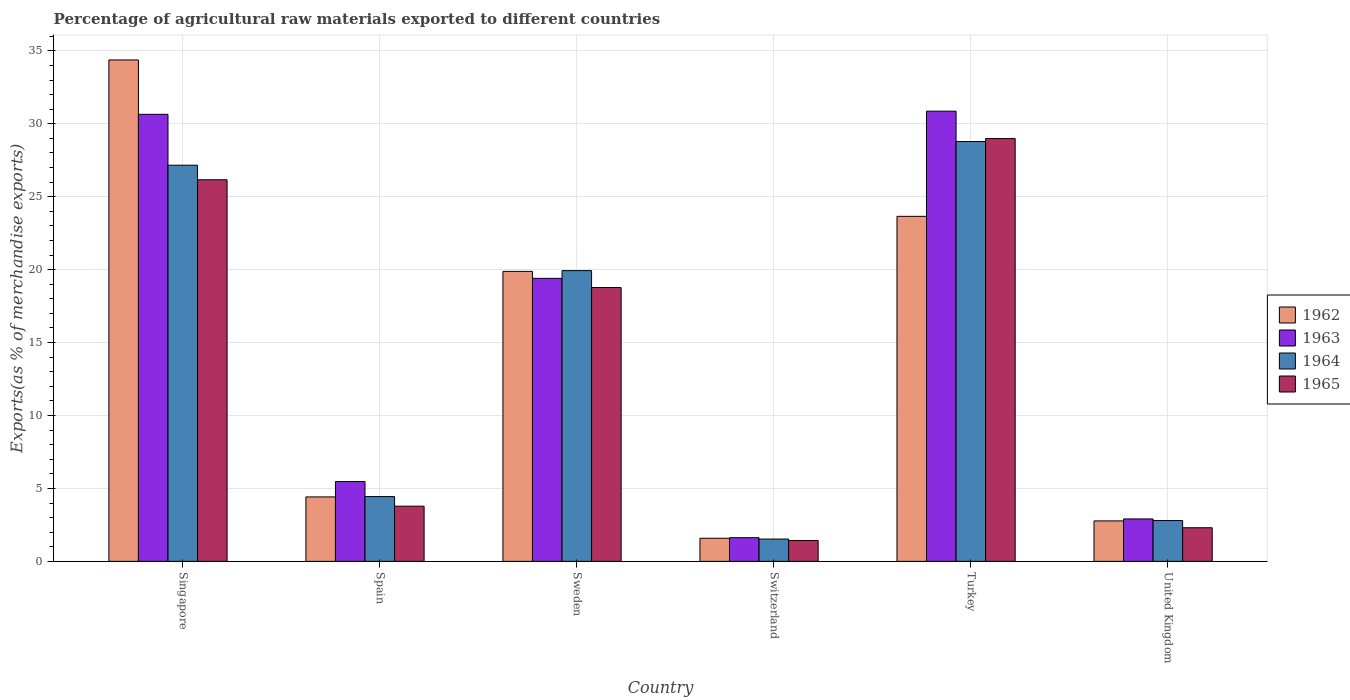Are the number of bars on each tick of the X-axis equal?
Ensure brevity in your answer.  Yes. How many bars are there on the 2nd tick from the right?
Provide a short and direct response. 4. What is the label of the 1st group of bars from the left?
Provide a short and direct response. Singapore. What is the percentage of exports to different countries in 1964 in Sweden?
Your answer should be very brief. 19.93. Across all countries, what is the maximum percentage of exports to different countries in 1964?
Offer a terse response. 28.78. Across all countries, what is the minimum percentage of exports to different countries in 1963?
Your answer should be compact. 1.62. In which country was the percentage of exports to different countries in 1964 minimum?
Keep it short and to the point. Switzerland. What is the total percentage of exports to different countries in 1964 in the graph?
Provide a succinct answer. 84.64. What is the difference between the percentage of exports to different countries in 1965 in Turkey and that in United Kingdom?
Your answer should be very brief. 26.68. What is the difference between the percentage of exports to different countries in 1965 in Switzerland and the percentage of exports to different countries in 1963 in United Kingdom?
Give a very brief answer. -1.48. What is the average percentage of exports to different countries in 1965 per country?
Provide a short and direct response. 13.57. What is the difference between the percentage of exports to different countries of/in 1963 and percentage of exports to different countries of/in 1962 in Spain?
Your answer should be very brief. 1.06. In how many countries, is the percentage of exports to different countries in 1965 greater than 29 %?
Offer a very short reply. 0. What is the ratio of the percentage of exports to different countries in 1964 in Singapore to that in United Kingdom?
Offer a very short reply. 9.71. What is the difference between the highest and the second highest percentage of exports to different countries in 1964?
Your answer should be compact. -7.23. What is the difference between the highest and the lowest percentage of exports to different countries in 1963?
Offer a terse response. 29.24. Is it the case that in every country, the sum of the percentage of exports to different countries in 1963 and percentage of exports to different countries in 1965 is greater than the sum of percentage of exports to different countries in 1962 and percentage of exports to different countries in 1964?
Provide a short and direct response. No. What does the 3rd bar from the left in Spain represents?
Provide a succinct answer. 1964. What does the 3rd bar from the right in United Kingdom represents?
Make the answer very short. 1963. How many countries are there in the graph?
Keep it short and to the point. 6. What is the difference between two consecutive major ticks on the Y-axis?
Provide a succinct answer. 5. Does the graph contain any zero values?
Keep it short and to the point. No. Does the graph contain grids?
Your answer should be very brief. Yes. Where does the legend appear in the graph?
Offer a terse response. Center right. How many legend labels are there?
Your answer should be compact. 4. What is the title of the graph?
Offer a terse response. Percentage of agricultural raw materials exported to different countries. Does "1981" appear as one of the legend labels in the graph?
Offer a terse response. No. What is the label or title of the X-axis?
Provide a short and direct response. Country. What is the label or title of the Y-axis?
Ensure brevity in your answer.  Exports(as % of merchandise exports). What is the Exports(as % of merchandise exports) of 1962 in Singapore?
Offer a very short reply. 34.38. What is the Exports(as % of merchandise exports) in 1963 in Singapore?
Your response must be concise. 30.65. What is the Exports(as % of merchandise exports) of 1964 in Singapore?
Your response must be concise. 27.16. What is the Exports(as % of merchandise exports) of 1965 in Singapore?
Make the answer very short. 26.16. What is the Exports(as % of merchandise exports) in 1962 in Spain?
Your response must be concise. 4.42. What is the Exports(as % of merchandise exports) of 1963 in Spain?
Your answer should be very brief. 5.47. What is the Exports(as % of merchandise exports) in 1964 in Spain?
Offer a very short reply. 4.44. What is the Exports(as % of merchandise exports) of 1965 in Spain?
Your answer should be very brief. 3.78. What is the Exports(as % of merchandise exports) of 1962 in Sweden?
Provide a succinct answer. 19.88. What is the Exports(as % of merchandise exports) in 1963 in Sweden?
Your answer should be compact. 19.4. What is the Exports(as % of merchandise exports) in 1964 in Sweden?
Keep it short and to the point. 19.93. What is the Exports(as % of merchandise exports) of 1965 in Sweden?
Give a very brief answer. 18.78. What is the Exports(as % of merchandise exports) of 1962 in Switzerland?
Make the answer very short. 1.58. What is the Exports(as % of merchandise exports) in 1963 in Switzerland?
Give a very brief answer. 1.62. What is the Exports(as % of merchandise exports) of 1964 in Switzerland?
Keep it short and to the point. 1.53. What is the Exports(as % of merchandise exports) in 1965 in Switzerland?
Your answer should be compact. 1.43. What is the Exports(as % of merchandise exports) in 1962 in Turkey?
Offer a terse response. 23.65. What is the Exports(as % of merchandise exports) of 1963 in Turkey?
Keep it short and to the point. 30.86. What is the Exports(as % of merchandise exports) in 1964 in Turkey?
Your answer should be very brief. 28.78. What is the Exports(as % of merchandise exports) in 1965 in Turkey?
Your answer should be compact. 28.99. What is the Exports(as % of merchandise exports) in 1962 in United Kingdom?
Offer a very short reply. 2.77. What is the Exports(as % of merchandise exports) of 1963 in United Kingdom?
Offer a very short reply. 2.91. What is the Exports(as % of merchandise exports) of 1964 in United Kingdom?
Your answer should be compact. 2.8. What is the Exports(as % of merchandise exports) of 1965 in United Kingdom?
Provide a succinct answer. 2.3. Across all countries, what is the maximum Exports(as % of merchandise exports) of 1962?
Your answer should be very brief. 34.38. Across all countries, what is the maximum Exports(as % of merchandise exports) of 1963?
Provide a short and direct response. 30.86. Across all countries, what is the maximum Exports(as % of merchandise exports) of 1964?
Give a very brief answer. 28.78. Across all countries, what is the maximum Exports(as % of merchandise exports) of 1965?
Give a very brief answer. 28.99. Across all countries, what is the minimum Exports(as % of merchandise exports) of 1962?
Ensure brevity in your answer.  1.58. Across all countries, what is the minimum Exports(as % of merchandise exports) in 1963?
Offer a very short reply. 1.62. Across all countries, what is the minimum Exports(as % of merchandise exports) of 1964?
Give a very brief answer. 1.53. Across all countries, what is the minimum Exports(as % of merchandise exports) in 1965?
Keep it short and to the point. 1.43. What is the total Exports(as % of merchandise exports) in 1962 in the graph?
Provide a succinct answer. 86.69. What is the total Exports(as % of merchandise exports) of 1963 in the graph?
Your response must be concise. 90.92. What is the total Exports(as % of merchandise exports) of 1964 in the graph?
Keep it short and to the point. 84.64. What is the total Exports(as % of merchandise exports) in 1965 in the graph?
Offer a very short reply. 81.44. What is the difference between the Exports(as % of merchandise exports) in 1962 in Singapore and that in Spain?
Provide a succinct answer. 29.96. What is the difference between the Exports(as % of merchandise exports) of 1963 in Singapore and that in Spain?
Your answer should be very brief. 25.18. What is the difference between the Exports(as % of merchandise exports) in 1964 in Singapore and that in Spain?
Ensure brevity in your answer.  22.72. What is the difference between the Exports(as % of merchandise exports) in 1965 in Singapore and that in Spain?
Ensure brevity in your answer.  22.38. What is the difference between the Exports(as % of merchandise exports) in 1962 in Singapore and that in Sweden?
Make the answer very short. 14.5. What is the difference between the Exports(as % of merchandise exports) in 1963 in Singapore and that in Sweden?
Offer a terse response. 11.25. What is the difference between the Exports(as % of merchandise exports) of 1964 in Singapore and that in Sweden?
Make the answer very short. 7.23. What is the difference between the Exports(as % of merchandise exports) in 1965 in Singapore and that in Sweden?
Ensure brevity in your answer.  7.39. What is the difference between the Exports(as % of merchandise exports) in 1962 in Singapore and that in Switzerland?
Your answer should be very brief. 32.79. What is the difference between the Exports(as % of merchandise exports) in 1963 in Singapore and that in Switzerland?
Provide a short and direct response. 29.02. What is the difference between the Exports(as % of merchandise exports) of 1964 in Singapore and that in Switzerland?
Make the answer very short. 25.63. What is the difference between the Exports(as % of merchandise exports) of 1965 in Singapore and that in Switzerland?
Your answer should be compact. 24.73. What is the difference between the Exports(as % of merchandise exports) in 1962 in Singapore and that in Turkey?
Offer a terse response. 10.72. What is the difference between the Exports(as % of merchandise exports) in 1963 in Singapore and that in Turkey?
Your answer should be very brief. -0.22. What is the difference between the Exports(as % of merchandise exports) of 1964 in Singapore and that in Turkey?
Make the answer very short. -1.62. What is the difference between the Exports(as % of merchandise exports) of 1965 in Singapore and that in Turkey?
Your response must be concise. -2.83. What is the difference between the Exports(as % of merchandise exports) in 1962 in Singapore and that in United Kingdom?
Offer a terse response. 31.6. What is the difference between the Exports(as % of merchandise exports) of 1963 in Singapore and that in United Kingdom?
Offer a very short reply. 27.74. What is the difference between the Exports(as % of merchandise exports) of 1964 in Singapore and that in United Kingdom?
Give a very brief answer. 24.36. What is the difference between the Exports(as % of merchandise exports) of 1965 in Singapore and that in United Kingdom?
Provide a short and direct response. 23.86. What is the difference between the Exports(as % of merchandise exports) of 1962 in Spain and that in Sweden?
Your answer should be compact. -15.46. What is the difference between the Exports(as % of merchandise exports) of 1963 in Spain and that in Sweden?
Your answer should be very brief. -13.93. What is the difference between the Exports(as % of merchandise exports) in 1964 in Spain and that in Sweden?
Give a very brief answer. -15.49. What is the difference between the Exports(as % of merchandise exports) in 1965 in Spain and that in Sweden?
Keep it short and to the point. -14.99. What is the difference between the Exports(as % of merchandise exports) of 1962 in Spain and that in Switzerland?
Your answer should be compact. 2.83. What is the difference between the Exports(as % of merchandise exports) of 1963 in Spain and that in Switzerland?
Ensure brevity in your answer.  3.85. What is the difference between the Exports(as % of merchandise exports) of 1964 in Spain and that in Switzerland?
Offer a very short reply. 2.91. What is the difference between the Exports(as % of merchandise exports) of 1965 in Spain and that in Switzerland?
Ensure brevity in your answer.  2.35. What is the difference between the Exports(as % of merchandise exports) of 1962 in Spain and that in Turkey?
Provide a succinct answer. -19.24. What is the difference between the Exports(as % of merchandise exports) in 1963 in Spain and that in Turkey?
Offer a very short reply. -25.39. What is the difference between the Exports(as % of merchandise exports) of 1964 in Spain and that in Turkey?
Ensure brevity in your answer.  -24.34. What is the difference between the Exports(as % of merchandise exports) of 1965 in Spain and that in Turkey?
Ensure brevity in your answer.  -25.21. What is the difference between the Exports(as % of merchandise exports) in 1962 in Spain and that in United Kingdom?
Ensure brevity in your answer.  1.64. What is the difference between the Exports(as % of merchandise exports) in 1963 in Spain and that in United Kingdom?
Offer a terse response. 2.56. What is the difference between the Exports(as % of merchandise exports) in 1964 in Spain and that in United Kingdom?
Keep it short and to the point. 1.64. What is the difference between the Exports(as % of merchandise exports) of 1965 in Spain and that in United Kingdom?
Ensure brevity in your answer.  1.48. What is the difference between the Exports(as % of merchandise exports) of 1962 in Sweden and that in Switzerland?
Your response must be concise. 18.3. What is the difference between the Exports(as % of merchandise exports) in 1963 in Sweden and that in Switzerland?
Your response must be concise. 17.78. What is the difference between the Exports(as % of merchandise exports) in 1964 in Sweden and that in Switzerland?
Provide a short and direct response. 18.4. What is the difference between the Exports(as % of merchandise exports) in 1965 in Sweden and that in Switzerland?
Offer a very short reply. 17.35. What is the difference between the Exports(as % of merchandise exports) of 1962 in Sweden and that in Turkey?
Provide a short and direct response. -3.77. What is the difference between the Exports(as % of merchandise exports) in 1963 in Sweden and that in Turkey?
Your response must be concise. -11.46. What is the difference between the Exports(as % of merchandise exports) in 1964 in Sweden and that in Turkey?
Make the answer very short. -8.85. What is the difference between the Exports(as % of merchandise exports) in 1965 in Sweden and that in Turkey?
Provide a succinct answer. -10.21. What is the difference between the Exports(as % of merchandise exports) in 1962 in Sweden and that in United Kingdom?
Give a very brief answer. 17.11. What is the difference between the Exports(as % of merchandise exports) in 1963 in Sweden and that in United Kingdom?
Make the answer very short. 16.49. What is the difference between the Exports(as % of merchandise exports) of 1964 in Sweden and that in United Kingdom?
Offer a terse response. 17.13. What is the difference between the Exports(as % of merchandise exports) of 1965 in Sweden and that in United Kingdom?
Make the answer very short. 16.47. What is the difference between the Exports(as % of merchandise exports) of 1962 in Switzerland and that in Turkey?
Provide a short and direct response. -22.07. What is the difference between the Exports(as % of merchandise exports) of 1963 in Switzerland and that in Turkey?
Offer a very short reply. -29.24. What is the difference between the Exports(as % of merchandise exports) of 1964 in Switzerland and that in Turkey?
Make the answer very short. -27.25. What is the difference between the Exports(as % of merchandise exports) in 1965 in Switzerland and that in Turkey?
Provide a succinct answer. -27.56. What is the difference between the Exports(as % of merchandise exports) of 1962 in Switzerland and that in United Kingdom?
Your answer should be compact. -1.19. What is the difference between the Exports(as % of merchandise exports) in 1963 in Switzerland and that in United Kingdom?
Keep it short and to the point. -1.28. What is the difference between the Exports(as % of merchandise exports) in 1964 in Switzerland and that in United Kingdom?
Your response must be concise. -1.27. What is the difference between the Exports(as % of merchandise exports) in 1965 in Switzerland and that in United Kingdom?
Make the answer very short. -0.87. What is the difference between the Exports(as % of merchandise exports) in 1962 in Turkey and that in United Kingdom?
Provide a succinct answer. 20.88. What is the difference between the Exports(as % of merchandise exports) of 1963 in Turkey and that in United Kingdom?
Provide a succinct answer. 27.96. What is the difference between the Exports(as % of merchandise exports) of 1964 in Turkey and that in United Kingdom?
Offer a terse response. 25.98. What is the difference between the Exports(as % of merchandise exports) of 1965 in Turkey and that in United Kingdom?
Make the answer very short. 26.68. What is the difference between the Exports(as % of merchandise exports) in 1962 in Singapore and the Exports(as % of merchandise exports) in 1963 in Spain?
Make the answer very short. 28.9. What is the difference between the Exports(as % of merchandise exports) of 1962 in Singapore and the Exports(as % of merchandise exports) of 1964 in Spain?
Provide a short and direct response. 29.94. What is the difference between the Exports(as % of merchandise exports) of 1962 in Singapore and the Exports(as % of merchandise exports) of 1965 in Spain?
Provide a short and direct response. 30.59. What is the difference between the Exports(as % of merchandise exports) of 1963 in Singapore and the Exports(as % of merchandise exports) of 1964 in Spain?
Offer a terse response. 26.21. What is the difference between the Exports(as % of merchandise exports) in 1963 in Singapore and the Exports(as % of merchandise exports) in 1965 in Spain?
Provide a succinct answer. 26.87. What is the difference between the Exports(as % of merchandise exports) in 1964 in Singapore and the Exports(as % of merchandise exports) in 1965 in Spain?
Provide a short and direct response. 23.38. What is the difference between the Exports(as % of merchandise exports) of 1962 in Singapore and the Exports(as % of merchandise exports) of 1963 in Sweden?
Offer a very short reply. 14.97. What is the difference between the Exports(as % of merchandise exports) in 1962 in Singapore and the Exports(as % of merchandise exports) in 1964 in Sweden?
Your response must be concise. 14.44. What is the difference between the Exports(as % of merchandise exports) of 1962 in Singapore and the Exports(as % of merchandise exports) of 1965 in Sweden?
Offer a terse response. 15.6. What is the difference between the Exports(as % of merchandise exports) in 1963 in Singapore and the Exports(as % of merchandise exports) in 1964 in Sweden?
Your response must be concise. 10.72. What is the difference between the Exports(as % of merchandise exports) in 1963 in Singapore and the Exports(as % of merchandise exports) in 1965 in Sweden?
Ensure brevity in your answer.  11.87. What is the difference between the Exports(as % of merchandise exports) of 1964 in Singapore and the Exports(as % of merchandise exports) of 1965 in Sweden?
Your answer should be very brief. 8.39. What is the difference between the Exports(as % of merchandise exports) of 1962 in Singapore and the Exports(as % of merchandise exports) of 1963 in Switzerland?
Give a very brief answer. 32.75. What is the difference between the Exports(as % of merchandise exports) of 1962 in Singapore and the Exports(as % of merchandise exports) of 1964 in Switzerland?
Your answer should be very brief. 32.85. What is the difference between the Exports(as % of merchandise exports) of 1962 in Singapore and the Exports(as % of merchandise exports) of 1965 in Switzerland?
Make the answer very short. 32.95. What is the difference between the Exports(as % of merchandise exports) in 1963 in Singapore and the Exports(as % of merchandise exports) in 1964 in Switzerland?
Keep it short and to the point. 29.12. What is the difference between the Exports(as % of merchandise exports) of 1963 in Singapore and the Exports(as % of merchandise exports) of 1965 in Switzerland?
Your answer should be very brief. 29.22. What is the difference between the Exports(as % of merchandise exports) of 1964 in Singapore and the Exports(as % of merchandise exports) of 1965 in Switzerland?
Your response must be concise. 25.73. What is the difference between the Exports(as % of merchandise exports) in 1962 in Singapore and the Exports(as % of merchandise exports) in 1963 in Turkey?
Your answer should be compact. 3.51. What is the difference between the Exports(as % of merchandise exports) in 1962 in Singapore and the Exports(as % of merchandise exports) in 1964 in Turkey?
Keep it short and to the point. 5.59. What is the difference between the Exports(as % of merchandise exports) in 1962 in Singapore and the Exports(as % of merchandise exports) in 1965 in Turkey?
Offer a very short reply. 5.39. What is the difference between the Exports(as % of merchandise exports) in 1963 in Singapore and the Exports(as % of merchandise exports) in 1964 in Turkey?
Provide a short and direct response. 1.87. What is the difference between the Exports(as % of merchandise exports) in 1963 in Singapore and the Exports(as % of merchandise exports) in 1965 in Turkey?
Ensure brevity in your answer.  1.66. What is the difference between the Exports(as % of merchandise exports) of 1964 in Singapore and the Exports(as % of merchandise exports) of 1965 in Turkey?
Your response must be concise. -1.83. What is the difference between the Exports(as % of merchandise exports) in 1962 in Singapore and the Exports(as % of merchandise exports) in 1963 in United Kingdom?
Ensure brevity in your answer.  31.47. What is the difference between the Exports(as % of merchandise exports) in 1962 in Singapore and the Exports(as % of merchandise exports) in 1964 in United Kingdom?
Keep it short and to the point. 31.58. What is the difference between the Exports(as % of merchandise exports) in 1962 in Singapore and the Exports(as % of merchandise exports) in 1965 in United Kingdom?
Provide a succinct answer. 32.07. What is the difference between the Exports(as % of merchandise exports) of 1963 in Singapore and the Exports(as % of merchandise exports) of 1964 in United Kingdom?
Make the answer very short. 27.85. What is the difference between the Exports(as % of merchandise exports) of 1963 in Singapore and the Exports(as % of merchandise exports) of 1965 in United Kingdom?
Keep it short and to the point. 28.34. What is the difference between the Exports(as % of merchandise exports) of 1964 in Singapore and the Exports(as % of merchandise exports) of 1965 in United Kingdom?
Offer a terse response. 24.86. What is the difference between the Exports(as % of merchandise exports) in 1962 in Spain and the Exports(as % of merchandise exports) in 1963 in Sweden?
Your response must be concise. -14.98. What is the difference between the Exports(as % of merchandise exports) in 1962 in Spain and the Exports(as % of merchandise exports) in 1964 in Sweden?
Offer a terse response. -15.51. What is the difference between the Exports(as % of merchandise exports) of 1962 in Spain and the Exports(as % of merchandise exports) of 1965 in Sweden?
Provide a short and direct response. -14.36. What is the difference between the Exports(as % of merchandise exports) in 1963 in Spain and the Exports(as % of merchandise exports) in 1964 in Sweden?
Offer a terse response. -14.46. What is the difference between the Exports(as % of merchandise exports) in 1963 in Spain and the Exports(as % of merchandise exports) in 1965 in Sweden?
Provide a succinct answer. -13.3. What is the difference between the Exports(as % of merchandise exports) in 1964 in Spain and the Exports(as % of merchandise exports) in 1965 in Sweden?
Offer a terse response. -14.33. What is the difference between the Exports(as % of merchandise exports) of 1962 in Spain and the Exports(as % of merchandise exports) of 1963 in Switzerland?
Offer a terse response. 2.79. What is the difference between the Exports(as % of merchandise exports) of 1962 in Spain and the Exports(as % of merchandise exports) of 1964 in Switzerland?
Offer a terse response. 2.89. What is the difference between the Exports(as % of merchandise exports) in 1962 in Spain and the Exports(as % of merchandise exports) in 1965 in Switzerland?
Provide a succinct answer. 2.99. What is the difference between the Exports(as % of merchandise exports) in 1963 in Spain and the Exports(as % of merchandise exports) in 1964 in Switzerland?
Make the answer very short. 3.94. What is the difference between the Exports(as % of merchandise exports) of 1963 in Spain and the Exports(as % of merchandise exports) of 1965 in Switzerland?
Provide a short and direct response. 4.04. What is the difference between the Exports(as % of merchandise exports) in 1964 in Spain and the Exports(as % of merchandise exports) in 1965 in Switzerland?
Ensure brevity in your answer.  3.01. What is the difference between the Exports(as % of merchandise exports) of 1962 in Spain and the Exports(as % of merchandise exports) of 1963 in Turkey?
Give a very brief answer. -26.45. What is the difference between the Exports(as % of merchandise exports) in 1962 in Spain and the Exports(as % of merchandise exports) in 1964 in Turkey?
Offer a very short reply. -24.36. What is the difference between the Exports(as % of merchandise exports) in 1962 in Spain and the Exports(as % of merchandise exports) in 1965 in Turkey?
Make the answer very short. -24.57. What is the difference between the Exports(as % of merchandise exports) of 1963 in Spain and the Exports(as % of merchandise exports) of 1964 in Turkey?
Give a very brief answer. -23.31. What is the difference between the Exports(as % of merchandise exports) of 1963 in Spain and the Exports(as % of merchandise exports) of 1965 in Turkey?
Ensure brevity in your answer.  -23.51. What is the difference between the Exports(as % of merchandise exports) of 1964 in Spain and the Exports(as % of merchandise exports) of 1965 in Turkey?
Offer a terse response. -24.55. What is the difference between the Exports(as % of merchandise exports) of 1962 in Spain and the Exports(as % of merchandise exports) of 1963 in United Kingdom?
Make the answer very short. 1.51. What is the difference between the Exports(as % of merchandise exports) in 1962 in Spain and the Exports(as % of merchandise exports) in 1964 in United Kingdom?
Ensure brevity in your answer.  1.62. What is the difference between the Exports(as % of merchandise exports) in 1962 in Spain and the Exports(as % of merchandise exports) in 1965 in United Kingdom?
Provide a short and direct response. 2.11. What is the difference between the Exports(as % of merchandise exports) of 1963 in Spain and the Exports(as % of merchandise exports) of 1964 in United Kingdom?
Give a very brief answer. 2.68. What is the difference between the Exports(as % of merchandise exports) of 1963 in Spain and the Exports(as % of merchandise exports) of 1965 in United Kingdom?
Offer a terse response. 3.17. What is the difference between the Exports(as % of merchandise exports) in 1964 in Spain and the Exports(as % of merchandise exports) in 1965 in United Kingdom?
Ensure brevity in your answer.  2.14. What is the difference between the Exports(as % of merchandise exports) in 1962 in Sweden and the Exports(as % of merchandise exports) in 1963 in Switzerland?
Keep it short and to the point. 18.26. What is the difference between the Exports(as % of merchandise exports) of 1962 in Sweden and the Exports(as % of merchandise exports) of 1964 in Switzerland?
Provide a short and direct response. 18.35. What is the difference between the Exports(as % of merchandise exports) in 1962 in Sweden and the Exports(as % of merchandise exports) in 1965 in Switzerland?
Keep it short and to the point. 18.45. What is the difference between the Exports(as % of merchandise exports) in 1963 in Sweden and the Exports(as % of merchandise exports) in 1964 in Switzerland?
Offer a very short reply. 17.87. What is the difference between the Exports(as % of merchandise exports) in 1963 in Sweden and the Exports(as % of merchandise exports) in 1965 in Switzerland?
Keep it short and to the point. 17.97. What is the difference between the Exports(as % of merchandise exports) in 1964 in Sweden and the Exports(as % of merchandise exports) in 1965 in Switzerland?
Make the answer very short. 18.5. What is the difference between the Exports(as % of merchandise exports) in 1962 in Sweden and the Exports(as % of merchandise exports) in 1963 in Turkey?
Offer a terse response. -10.98. What is the difference between the Exports(as % of merchandise exports) in 1962 in Sweden and the Exports(as % of merchandise exports) in 1964 in Turkey?
Keep it short and to the point. -8.9. What is the difference between the Exports(as % of merchandise exports) of 1962 in Sweden and the Exports(as % of merchandise exports) of 1965 in Turkey?
Provide a succinct answer. -9.11. What is the difference between the Exports(as % of merchandise exports) in 1963 in Sweden and the Exports(as % of merchandise exports) in 1964 in Turkey?
Give a very brief answer. -9.38. What is the difference between the Exports(as % of merchandise exports) of 1963 in Sweden and the Exports(as % of merchandise exports) of 1965 in Turkey?
Your answer should be very brief. -9.59. What is the difference between the Exports(as % of merchandise exports) of 1964 in Sweden and the Exports(as % of merchandise exports) of 1965 in Turkey?
Provide a short and direct response. -9.06. What is the difference between the Exports(as % of merchandise exports) of 1962 in Sweden and the Exports(as % of merchandise exports) of 1963 in United Kingdom?
Offer a very short reply. 16.97. What is the difference between the Exports(as % of merchandise exports) in 1962 in Sweden and the Exports(as % of merchandise exports) in 1964 in United Kingdom?
Give a very brief answer. 17.08. What is the difference between the Exports(as % of merchandise exports) in 1962 in Sweden and the Exports(as % of merchandise exports) in 1965 in United Kingdom?
Make the answer very short. 17.58. What is the difference between the Exports(as % of merchandise exports) of 1963 in Sweden and the Exports(as % of merchandise exports) of 1964 in United Kingdom?
Provide a short and direct response. 16.6. What is the difference between the Exports(as % of merchandise exports) in 1963 in Sweden and the Exports(as % of merchandise exports) in 1965 in United Kingdom?
Your answer should be very brief. 17.1. What is the difference between the Exports(as % of merchandise exports) of 1964 in Sweden and the Exports(as % of merchandise exports) of 1965 in United Kingdom?
Your answer should be very brief. 17.63. What is the difference between the Exports(as % of merchandise exports) in 1962 in Switzerland and the Exports(as % of merchandise exports) in 1963 in Turkey?
Give a very brief answer. -29.28. What is the difference between the Exports(as % of merchandise exports) of 1962 in Switzerland and the Exports(as % of merchandise exports) of 1964 in Turkey?
Keep it short and to the point. -27.2. What is the difference between the Exports(as % of merchandise exports) of 1962 in Switzerland and the Exports(as % of merchandise exports) of 1965 in Turkey?
Ensure brevity in your answer.  -27.4. What is the difference between the Exports(as % of merchandise exports) of 1963 in Switzerland and the Exports(as % of merchandise exports) of 1964 in Turkey?
Your answer should be very brief. -27.16. What is the difference between the Exports(as % of merchandise exports) of 1963 in Switzerland and the Exports(as % of merchandise exports) of 1965 in Turkey?
Give a very brief answer. -27.36. What is the difference between the Exports(as % of merchandise exports) of 1964 in Switzerland and the Exports(as % of merchandise exports) of 1965 in Turkey?
Keep it short and to the point. -27.46. What is the difference between the Exports(as % of merchandise exports) of 1962 in Switzerland and the Exports(as % of merchandise exports) of 1963 in United Kingdom?
Offer a terse response. -1.32. What is the difference between the Exports(as % of merchandise exports) of 1962 in Switzerland and the Exports(as % of merchandise exports) of 1964 in United Kingdom?
Your response must be concise. -1.21. What is the difference between the Exports(as % of merchandise exports) in 1962 in Switzerland and the Exports(as % of merchandise exports) in 1965 in United Kingdom?
Provide a succinct answer. -0.72. What is the difference between the Exports(as % of merchandise exports) in 1963 in Switzerland and the Exports(as % of merchandise exports) in 1964 in United Kingdom?
Your answer should be very brief. -1.17. What is the difference between the Exports(as % of merchandise exports) of 1963 in Switzerland and the Exports(as % of merchandise exports) of 1965 in United Kingdom?
Keep it short and to the point. -0.68. What is the difference between the Exports(as % of merchandise exports) in 1964 in Switzerland and the Exports(as % of merchandise exports) in 1965 in United Kingdom?
Your answer should be very brief. -0.78. What is the difference between the Exports(as % of merchandise exports) of 1962 in Turkey and the Exports(as % of merchandise exports) of 1963 in United Kingdom?
Offer a very short reply. 20.75. What is the difference between the Exports(as % of merchandise exports) of 1962 in Turkey and the Exports(as % of merchandise exports) of 1964 in United Kingdom?
Ensure brevity in your answer.  20.86. What is the difference between the Exports(as % of merchandise exports) of 1962 in Turkey and the Exports(as % of merchandise exports) of 1965 in United Kingdom?
Give a very brief answer. 21.35. What is the difference between the Exports(as % of merchandise exports) of 1963 in Turkey and the Exports(as % of merchandise exports) of 1964 in United Kingdom?
Keep it short and to the point. 28.07. What is the difference between the Exports(as % of merchandise exports) of 1963 in Turkey and the Exports(as % of merchandise exports) of 1965 in United Kingdom?
Offer a very short reply. 28.56. What is the difference between the Exports(as % of merchandise exports) in 1964 in Turkey and the Exports(as % of merchandise exports) in 1965 in United Kingdom?
Offer a very short reply. 26.48. What is the average Exports(as % of merchandise exports) in 1962 per country?
Offer a very short reply. 14.45. What is the average Exports(as % of merchandise exports) in 1963 per country?
Ensure brevity in your answer.  15.15. What is the average Exports(as % of merchandise exports) of 1964 per country?
Ensure brevity in your answer.  14.11. What is the average Exports(as % of merchandise exports) of 1965 per country?
Your response must be concise. 13.57. What is the difference between the Exports(as % of merchandise exports) in 1962 and Exports(as % of merchandise exports) in 1963 in Singapore?
Provide a succinct answer. 3.73. What is the difference between the Exports(as % of merchandise exports) in 1962 and Exports(as % of merchandise exports) in 1964 in Singapore?
Your response must be concise. 7.22. What is the difference between the Exports(as % of merchandise exports) in 1962 and Exports(as % of merchandise exports) in 1965 in Singapore?
Offer a very short reply. 8.22. What is the difference between the Exports(as % of merchandise exports) of 1963 and Exports(as % of merchandise exports) of 1964 in Singapore?
Provide a succinct answer. 3.49. What is the difference between the Exports(as % of merchandise exports) of 1963 and Exports(as % of merchandise exports) of 1965 in Singapore?
Your answer should be very brief. 4.49. What is the difference between the Exports(as % of merchandise exports) of 1962 and Exports(as % of merchandise exports) of 1963 in Spain?
Provide a succinct answer. -1.06. What is the difference between the Exports(as % of merchandise exports) of 1962 and Exports(as % of merchandise exports) of 1964 in Spain?
Give a very brief answer. -0.02. What is the difference between the Exports(as % of merchandise exports) of 1962 and Exports(as % of merchandise exports) of 1965 in Spain?
Provide a succinct answer. 0.64. What is the difference between the Exports(as % of merchandise exports) in 1963 and Exports(as % of merchandise exports) in 1964 in Spain?
Provide a short and direct response. 1.03. What is the difference between the Exports(as % of merchandise exports) in 1963 and Exports(as % of merchandise exports) in 1965 in Spain?
Ensure brevity in your answer.  1.69. What is the difference between the Exports(as % of merchandise exports) in 1964 and Exports(as % of merchandise exports) in 1965 in Spain?
Offer a very short reply. 0.66. What is the difference between the Exports(as % of merchandise exports) of 1962 and Exports(as % of merchandise exports) of 1963 in Sweden?
Keep it short and to the point. 0.48. What is the difference between the Exports(as % of merchandise exports) of 1962 and Exports(as % of merchandise exports) of 1964 in Sweden?
Provide a succinct answer. -0.05. What is the difference between the Exports(as % of merchandise exports) in 1962 and Exports(as % of merchandise exports) in 1965 in Sweden?
Your answer should be compact. 1.1. What is the difference between the Exports(as % of merchandise exports) of 1963 and Exports(as % of merchandise exports) of 1964 in Sweden?
Your answer should be very brief. -0.53. What is the difference between the Exports(as % of merchandise exports) of 1963 and Exports(as % of merchandise exports) of 1965 in Sweden?
Your answer should be very brief. 0.63. What is the difference between the Exports(as % of merchandise exports) of 1964 and Exports(as % of merchandise exports) of 1965 in Sweden?
Offer a terse response. 1.16. What is the difference between the Exports(as % of merchandise exports) of 1962 and Exports(as % of merchandise exports) of 1963 in Switzerland?
Your response must be concise. -0.04. What is the difference between the Exports(as % of merchandise exports) in 1962 and Exports(as % of merchandise exports) in 1964 in Switzerland?
Offer a terse response. 0.06. What is the difference between the Exports(as % of merchandise exports) in 1962 and Exports(as % of merchandise exports) in 1965 in Switzerland?
Your response must be concise. 0.15. What is the difference between the Exports(as % of merchandise exports) in 1963 and Exports(as % of merchandise exports) in 1964 in Switzerland?
Your response must be concise. 0.1. What is the difference between the Exports(as % of merchandise exports) in 1963 and Exports(as % of merchandise exports) in 1965 in Switzerland?
Offer a very short reply. 0.19. What is the difference between the Exports(as % of merchandise exports) in 1964 and Exports(as % of merchandise exports) in 1965 in Switzerland?
Offer a terse response. 0.1. What is the difference between the Exports(as % of merchandise exports) in 1962 and Exports(as % of merchandise exports) in 1963 in Turkey?
Ensure brevity in your answer.  -7.21. What is the difference between the Exports(as % of merchandise exports) of 1962 and Exports(as % of merchandise exports) of 1964 in Turkey?
Your answer should be compact. -5.13. What is the difference between the Exports(as % of merchandise exports) of 1962 and Exports(as % of merchandise exports) of 1965 in Turkey?
Ensure brevity in your answer.  -5.33. What is the difference between the Exports(as % of merchandise exports) in 1963 and Exports(as % of merchandise exports) in 1964 in Turkey?
Provide a short and direct response. 2.08. What is the difference between the Exports(as % of merchandise exports) in 1963 and Exports(as % of merchandise exports) in 1965 in Turkey?
Keep it short and to the point. 1.88. What is the difference between the Exports(as % of merchandise exports) in 1964 and Exports(as % of merchandise exports) in 1965 in Turkey?
Provide a succinct answer. -0.21. What is the difference between the Exports(as % of merchandise exports) of 1962 and Exports(as % of merchandise exports) of 1963 in United Kingdom?
Ensure brevity in your answer.  -0.13. What is the difference between the Exports(as % of merchandise exports) in 1962 and Exports(as % of merchandise exports) in 1964 in United Kingdom?
Ensure brevity in your answer.  -0.02. What is the difference between the Exports(as % of merchandise exports) of 1962 and Exports(as % of merchandise exports) of 1965 in United Kingdom?
Offer a very short reply. 0.47. What is the difference between the Exports(as % of merchandise exports) of 1963 and Exports(as % of merchandise exports) of 1964 in United Kingdom?
Keep it short and to the point. 0.11. What is the difference between the Exports(as % of merchandise exports) of 1963 and Exports(as % of merchandise exports) of 1965 in United Kingdom?
Offer a very short reply. 0.6. What is the difference between the Exports(as % of merchandise exports) in 1964 and Exports(as % of merchandise exports) in 1965 in United Kingdom?
Your answer should be very brief. 0.49. What is the ratio of the Exports(as % of merchandise exports) in 1962 in Singapore to that in Spain?
Your answer should be very brief. 7.78. What is the ratio of the Exports(as % of merchandise exports) in 1963 in Singapore to that in Spain?
Your answer should be compact. 5.6. What is the ratio of the Exports(as % of merchandise exports) of 1964 in Singapore to that in Spain?
Keep it short and to the point. 6.12. What is the ratio of the Exports(as % of merchandise exports) in 1965 in Singapore to that in Spain?
Give a very brief answer. 6.92. What is the ratio of the Exports(as % of merchandise exports) in 1962 in Singapore to that in Sweden?
Make the answer very short. 1.73. What is the ratio of the Exports(as % of merchandise exports) in 1963 in Singapore to that in Sweden?
Your answer should be very brief. 1.58. What is the ratio of the Exports(as % of merchandise exports) in 1964 in Singapore to that in Sweden?
Offer a terse response. 1.36. What is the ratio of the Exports(as % of merchandise exports) of 1965 in Singapore to that in Sweden?
Ensure brevity in your answer.  1.39. What is the ratio of the Exports(as % of merchandise exports) of 1962 in Singapore to that in Switzerland?
Offer a terse response. 21.7. What is the ratio of the Exports(as % of merchandise exports) in 1963 in Singapore to that in Switzerland?
Offer a terse response. 18.87. What is the ratio of the Exports(as % of merchandise exports) of 1964 in Singapore to that in Switzerland?
Give a very brief answer. 17.76. What is the ratio of the Exports(as % of merchandise exports) in 1965 in Singapore to that in Switzerland?
Your answer should be very brief. 18.29. What is the ratio of the Exports(as % of merchandise exports) of 1962 in Singapore to that in Turkey?
Your answer should be very brief. 1.45. What is the ratio of the Exports(as % of merchandise exports) of 1963 in Singapore to that in Turkey?
Offer a very short reply. 0.99. What is the ratio of the Exports(as % of merchandise exports) of 1964 in Singapore to that in Turkey?
Offer a very short reply. 0.94. What is the ratio of the Exports(as % of merchandise exports) of 1965 in Singapore to that in Turkey?
Offer a very short reply. 0.9. What is the ratio of the Exports(as % of merchandise exports) of 1962 in Singapore to that in United Kingdom?
Ensure brevity in your answer.  12.39. What is the ratio of the Exports(as % of merchandise exports) of 1963 in Singapore to that in United Kingdom?
Make the answer very short. 10.54. What is the ratio of the Exports(as % of merchandise exports) of 1964 in Singapore to that in United Kingdom?
Give a very brief answer. 9.71. What is the ratio of the Exports(as % of merchandise exports) in 1965 in Singapore to that in United Kingdom?
Provide a succinct answer. 11.35. What is the ratio of the Exports(as % of merchandise exports) of 1962 in Spain to that in Sweden?
Keep it short and to the point. 0.22. What is the ratio of the Exports(as % of merchandise exports) in 1963 in Spain to that in Sweden?
Provide a short and direct response. 0.28. What is the ratio of the Exports(as % of merchandise exports) of 1964 in Spain to that in Sweden?
Provide a succinct answer. 0.22. What is the ratio of the Exports(as % of merchandise exports) in 1965 in Spain to that in Sweden?
Keep it short and to the point. 0.2. What is the ratio of the Exports(as % of merchandise exports) in 1962 in Spain to that in Switzerland?
Provide a succinct answer. 2.79. What is the ratio of the Exports(as % of merchandise exports) of 1963 in Spain to that in Switzerland?
Your answer should be compact. 3.37. What is the ratio of the Exports(as % of merchandise exports) in 1964 in Spain to that in Switzerland?
Provide a short and direct response. 2.9. What is the ratio of the Exports(as % of merchandise exports) in 1965 in Spain to that in Switzerland?
Your answer should be compact. 2.65. What is the ratio of the Exports(as % of merchandise exports) of 1962 in Spain to that in Turkey?
Ensure brevity in your answer.  0.19. What is the ratio of the Exports(as % of merchandise exports) in 1963 in Spain to that in Turkey?
Make the answer very short. 0.18. What is the ratio of the Exports(as % of merchandise exports) in 1964 in Spain to that in Turkey?
Give a very brief answer. 0.15. What is the ratio of the Exports(as % of merchandise exports) of 1965 in Spain to that in Turkey?
Your response must be concise. 0.13. What is the ratio of the Exports(as % of merchandise exports) in 1962 in Spain to that in United Kingdom?
Make the answer very short. 1.59. What is the ratio of the Exports(as % of merchandise exports) of 1963 in Spain to that in United Kingdom?
Provide a succinct answer. 1.88. What is the ratio of the Exports(as % of merchandise exports) of 1964 in Spain to that in United Kingdom?
Provide a succinct answer. 1.59. What is the ratio of the Exports(as % of merchandise exports) in 1965 in Spain to that in United Kingdom?
Your answer should be very brief. 1.64. What is the ratio of the Exports(as % of merchandise exports) in 1962 in Sweden to that in Switzerland?
Keep it short and to the point. 12.55. What is the ratio of the Exports(as % of merchandise exports) in 1963 in Sweden to that in Switzerland?
Ensure brevity in your answer.  11.95. What is the ratio of the Exports(as % of merchandise exports) in 1964 in Sweden to that in Switzerland?
Your answer should be compact. 13.04. What is the ratio of the Exports(as % of merchandise exports) in 1965 in Sweden to that in Switzerland?
Make the answer very short. 13.13. What is the ratio of the Exports(as % of merchandise exports) of 1962 in Sweden to that in Turkey?
Give a very brief answer. 0.84. What is the ratio of the Exports(as % of merchandise exports) in 1963 in Sweden to that in Turkey?
Keep it short and to the point. 0.63. What is the ratio of the Exports(as % of merchandise exports) of 1964 in Sweden to that in Turkey?
Your response must be concise. 0.69. What is the ratio of the Exports(as % of merchandise exports) in 1965 in Sweden to that in Turkey?
Your answer should be very brief. 0.65. What is the ratio of the Exports(as % of merchandise exports) in 1962 in Sweden to that in United Kingdom?
Your response must be concise. 7.17. What is the ratio of the Exports(as % of merchandise exports) in 1963 in Sweden to that in United Kingdom?
Offer a terse response. 6.67. What is the ratio of the Exports(as % of merchandise exports) of 1964 in Sweden to that in United Kingdom?
Your response must be concise. 7.12. What is the ratio of the Exports(as % of merchandise exports) in 1965 in Sweden to that in United Kingdom?
Provide a short and direct response. 8.15. What is the ratio of the Exports(as % of merchandise exports) of 1962 in Switzerland to that in Turkey?
Your answer should be compact. 0.07. What is the ratio of the Exports(as % of merchandise exports) in 1963 in Switzerland to that in Turkey?
Make the answer very short. 0.05. What is the ratio of the Exports(as % of merchandise exports) in 1964 in Switzerland to that in Turkey?
Offer a terse response. 0.05. What is the ratio of the Exports(as % of merchandise exports) of 1965 in Switzerland to that in Turkey?
Keep it short and to the point. 0.05. What is the ratio of the Exports(as % of merchandise exports) in 1962 in Switzerland to that in United Kingdom?
Keep it short and to the point. 0.57. What is the ratio of the Exports(as % of merchandise exports) in 1963 in Switzerland to that in United Kingdom?
Your answer should be compact. 0.56. What is the ratio of the Exports(as % of merchandise exports) of 1964 in Switzerland to that in United Kingdom?
Provide a succinct answer. 0.55. What is the ratio of the Exports(as % of merchandise exports) of 1965 in Switzerland to that in United Kingdom?
Ensure brevity in your answer.  0.62. What is the ratio of the Exports(as % of merchandise exports) in 1962 in Turkey to that in United Kingdom?
Offer a terse response. 8.53. What is the ratio of the Exports(as % of merchandise exports) of 1963 in Turkey to that in United Kingdom?
Your answer should be compact. 10.61. What is the ratio of the Exports(as % of merchandise exports) of 1964 in Turkey to that in United Kingdom?
Your answer should be compact. 10.28. What is the ratio of the Exports(as % of merchandise exports) in 1965 in Turkey to that in United Kingdom?
Give a very brief answer. 12.58. What is the difference between the highest and the second highest Exports(as % of merchandise exports) in 1962?
Your answer should be compact. 10.72. What is the difference between the highest and the second highest Exports(as % of merchandise exports) in 1963?
Your answer should be very brief. 0.22. What is the difference between the highest and the second highest Exports(as % of merchandise exports) in 1964?
Keep it short and to the point. 1.62. What is the difference between the highest and the second highest Exports(as % of merchandise exports) in 1965?
Offer a very short reply. 2.83. What is the difference between the highest and the lowest Exports(as % of merchandise exports) in 1962?
Keep it short and to the point. 32.79. What is the difference between the highest and the lowest Exports(as % of merchandise exports) in 1963?
Ensure brevity in your answer.  29.24. What is the difference between the highest and the lowest Exports(as % of merchandise exports) of 1964?
Ensure brevity in your answer.  27.25. What is the difference between the highest and the lowest Exports(as % of merchandise exports) of 1965?
Your answer should be compact. 27.56. 